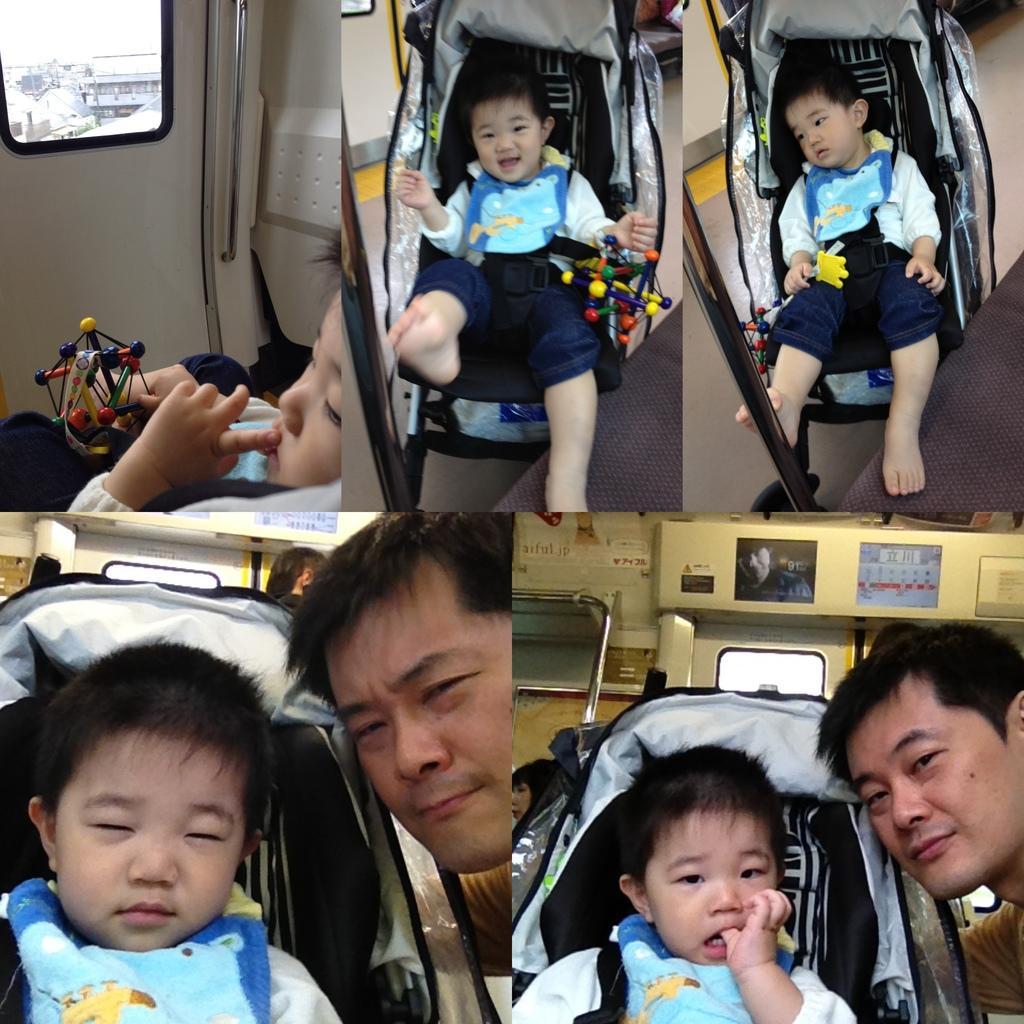Please provide a concise description of this image. This image consists of a boy and a man. It looks like the image is a edited and made as a collage. And it is clicked in the aircraft. The boy is sitting in a trolley. To the left, there is a door. 